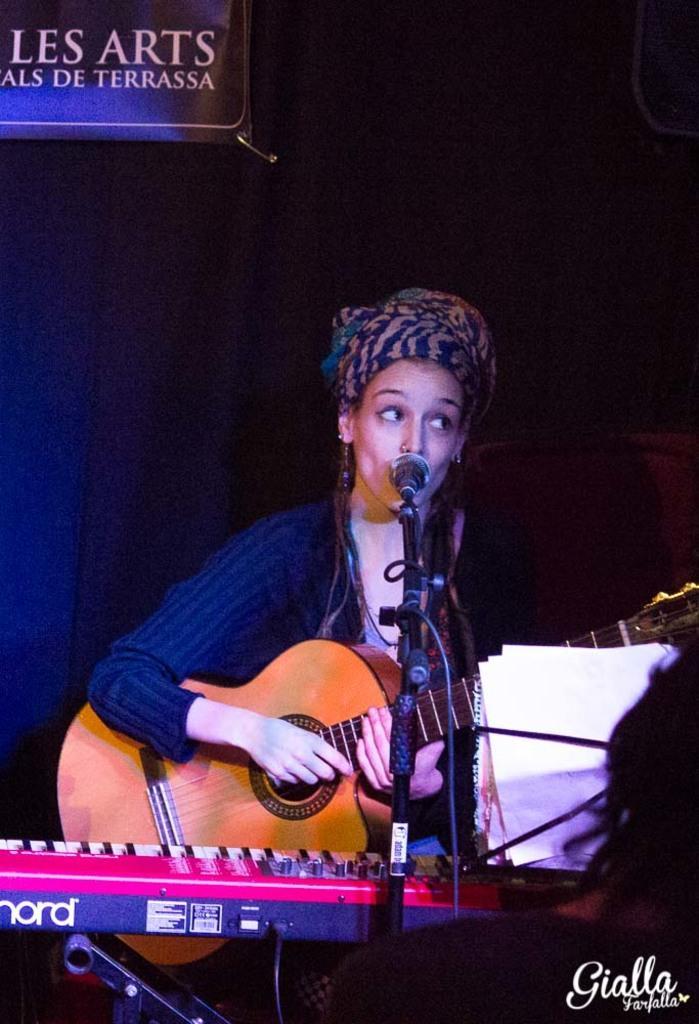Can you describe this image briefly? in this picture there is a girl who is standing at the center of the image by holding a guitar in her hand, there is a piano which is placed in front of the girl and there is a mic at the center of the image. 